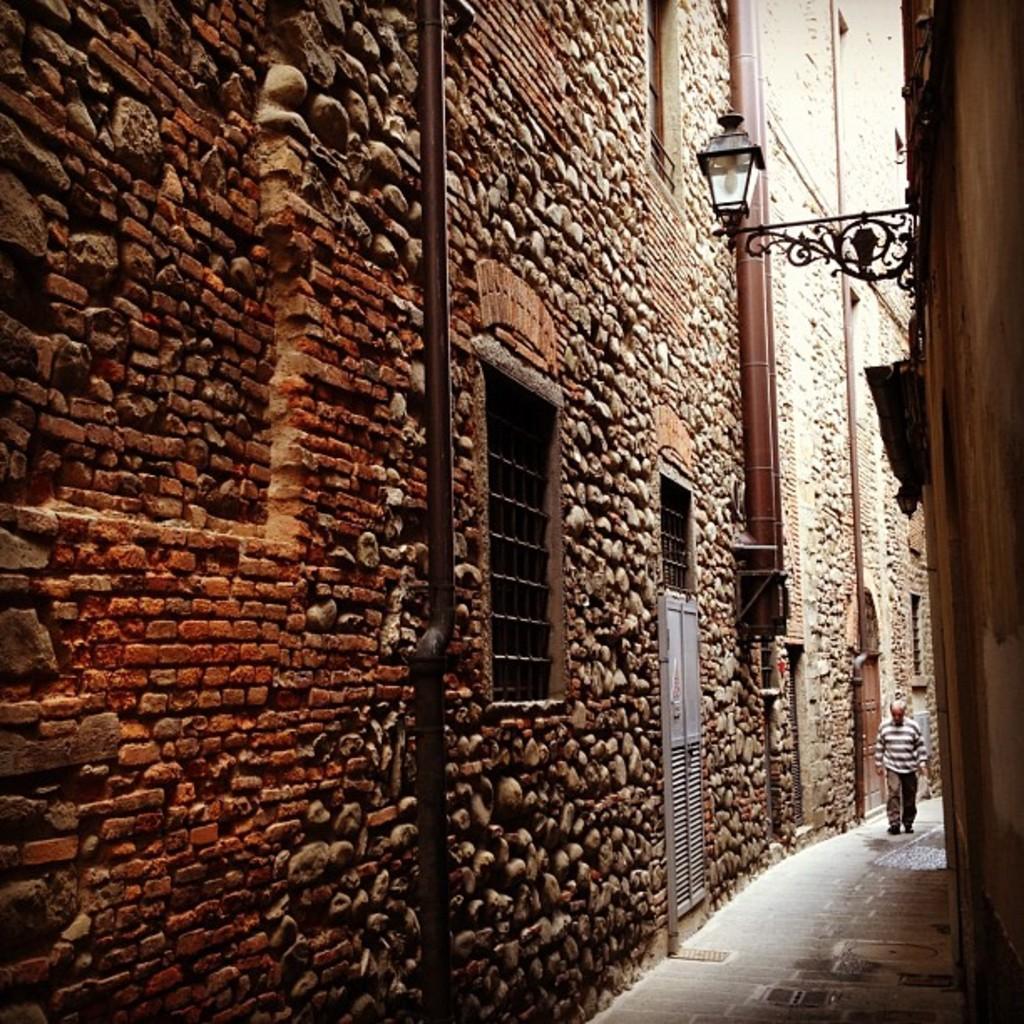Describe this image in one or two sentences. In this image I can see a building wall, pipes, windows, doors, lamp and a person on the road. This image is taken during a day. 